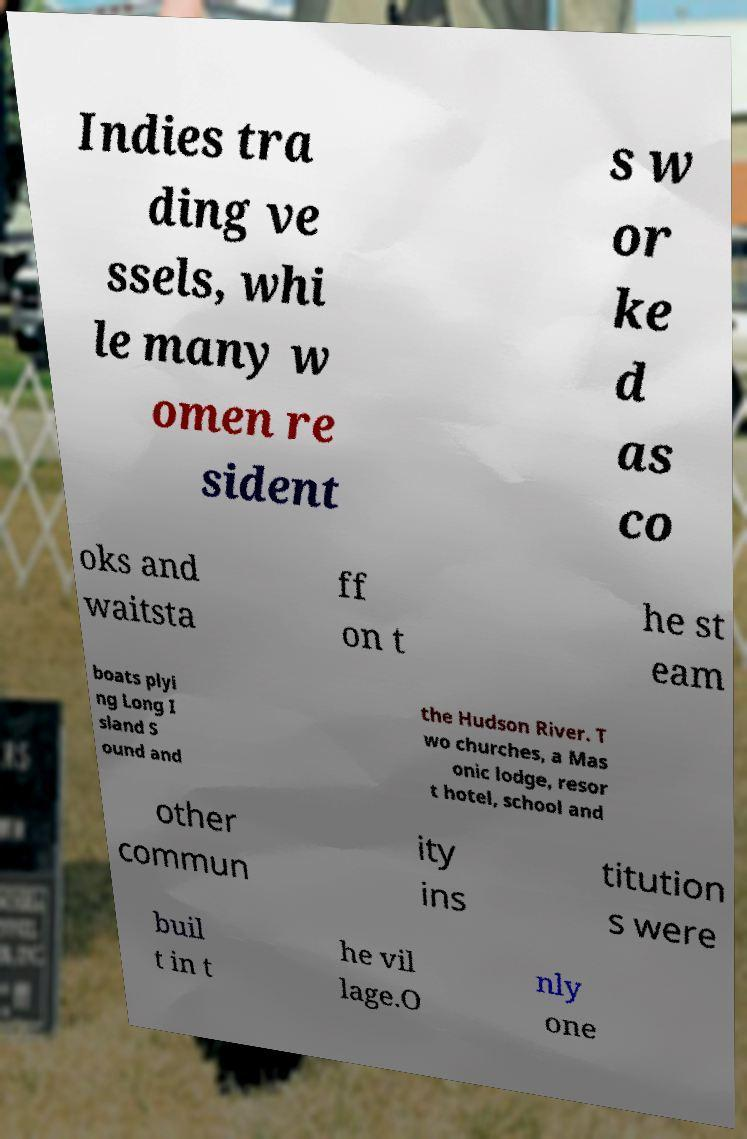Please read and relay the text visible in this image. What does it say? Indies tra ding ve ssels, whi le many w omen re sident s w or ke d as co oks and waitsta ff on t he st eam boats plyi ng Long I sland S ound and the Hudson River. T wo churches, a Mas onic lodge, resor t hotel, school and other commun ity ins titution s were buil t in t he vil lage.O nly one 